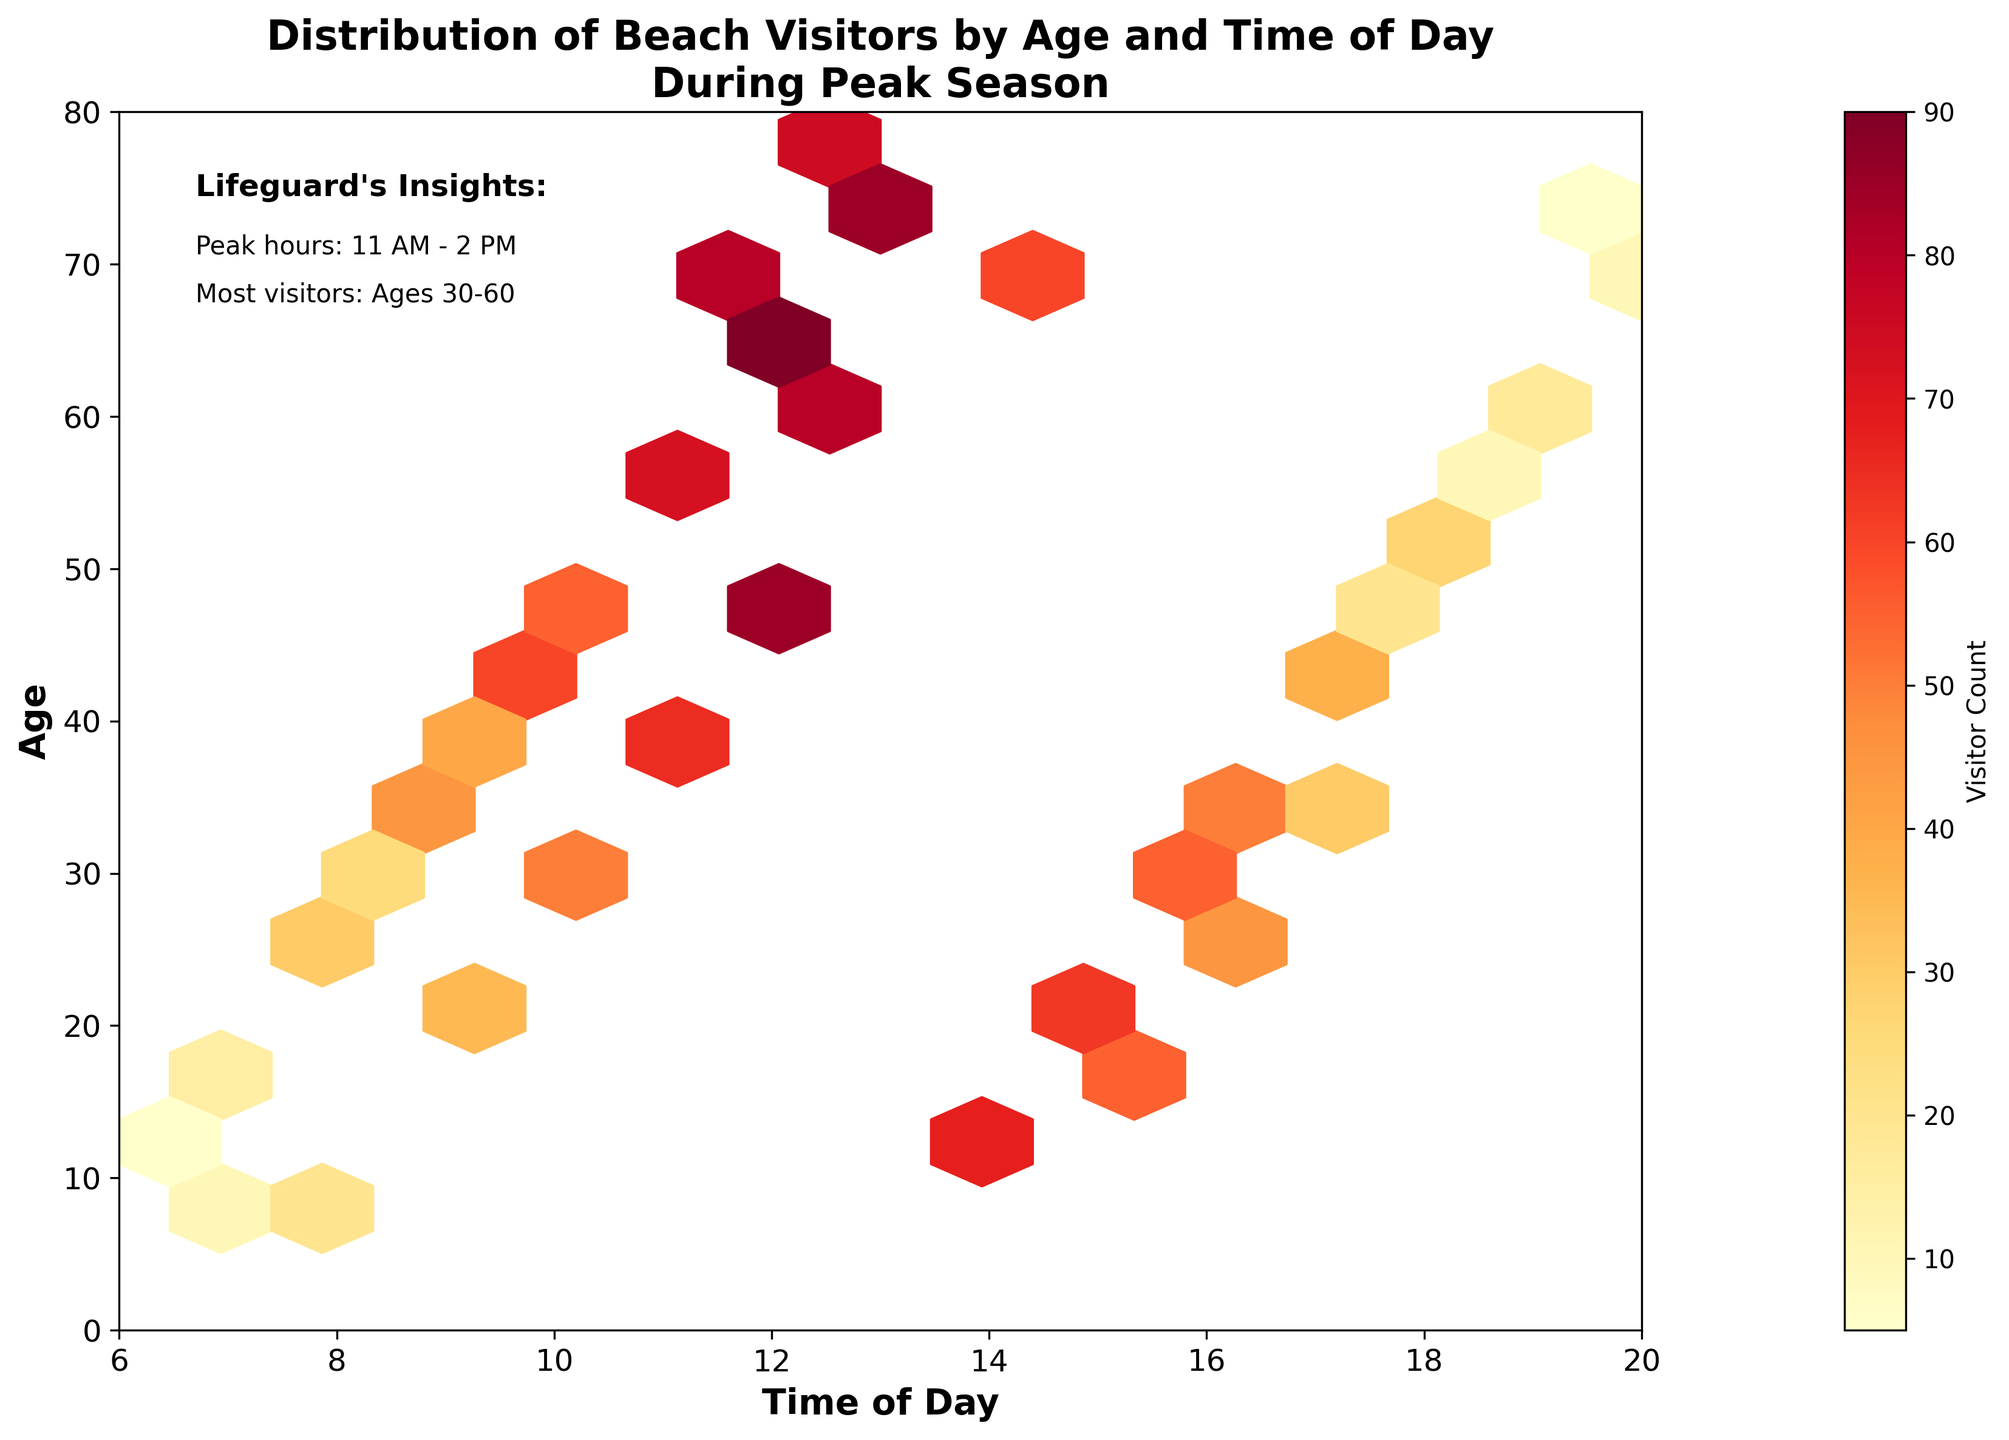What is the title of the hexbin plot? The title of a plot is usually displayed at the top and provides an overview of what the plot is about.
Answer: Distribution of Beach Visitors by Age and Time of Day During Peak Season What is the range of the x-axis? The x-axis range can be determined by looking at the labels on the x-axis, which represent different times of the day.
Answer: 6 to 20 Which time of day has the highest concentration of visitors according to the color gradient? In a hexbin plot, the color gradient indicates density, with darker colors representing higher concentrations. The time with the darkest hexagons has the highest visitor concentration.
Answer: 11 AM - 2 PM How many age groups are most frequently at the beach between 11 AM and 2 PM? Identify the age range with the highest density of hexagons in the time frame 11 AM to 2 PM using the color gradient.
Answer: Ages 30-60 Is the visitor count at 8 AM higher or lower than at 6 PM for ages 25-35? Compare the color intensity of hexagons at 8 AM and 6 PM for the specified age range (25-35).
Answer: Higher at 8 AM What is the visitor count for the age group 75 at 1 PM? Locate the hexagon that corresponds to the specified age and time, then use the color bar to determine the visitor count.
Answer: 85 At what age do visitors start to show a significant decrease after 2 PM? Observe the decrease in hexagon density and color intensity after 2 PM across different age groups.
Answer: Around age 30 Are there more visitors aged 40 or visitors aged 50 at noon? Compare the color intensity of hexagons for age groups 40 and 50 at 12 PM.
Answer: Visitors aged 50 What is the peak hour for visitors aged 60 and above? Trace the color intensity for the age group 60 and above across different times of the day to find the peak hour.
Answer: 12 PM - 1 PM How does the visitor trend change as the day progresses for ages 15-25? Analyze the change in hexagon density and color gradient from morning to evening for ages 15-25.
Answer: Peaks around 2 PM, then decreases 